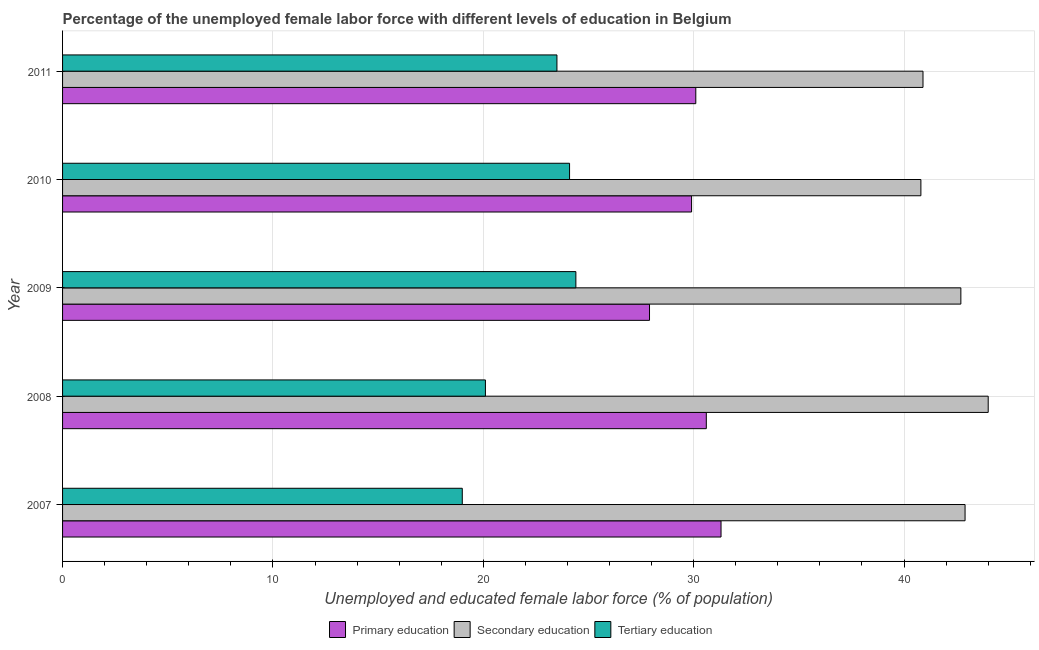How many different coloured bars are there?
Your answer should be very brief. 3. How many groups of bars are there?
Give a very brief answer. 5. Are the number of bars per tick equal to the number of legend labels?
Keep it short and to the point. Yes. How many bars are there on the 4th tick from the top?
Give a very brief answer. 3. How many bars are there on the 5th tick from the bottom?
Provide a short and direct response. 3. What is the label of the 1st group of bars from the top?
Offer a terse response. 2011. In how many cases, is the number of bars for a given year not equal to the number of legend labels?
Offer a very short reply. 0. What is the percentage of female labor force who received tertiary education in 2010?
Ensure brevity in your answer.  24.1. Across all years, what is the maximum percentage of female labor force who received secondary education?
Your response must be concise. 44. Across all years, what is the minimum percentage of female labor force who received tertiary education?
Provide a succinct answer. 19. In which year was the percentage of female labor force who received secondary education maximum?
Offer a very short reply. 2008. What is the total percentage of female labor force who received secondary education in the graph?
Your response must be concise. 211.3. What is the difference between the percentage of female labor force who received primary education in 2007 and the percentage of female labor force who received tertiary education in 2011?
Offer a very short reply. 7.8. What is the average percentage of female labor force who received tertiary education per year?
Ensure brevity in your answer.  22.22. What is the ratio of the percentage of female labor force who received secondary education in 2007 to that in 2010?
Give a very brief answer. 1.05. Is the percentage of female labor force who received primary education in 2009 less than that in 2011?
Offer a terse response. Yes. What is the difference between the highest and the lowest percentage of female labor force who received primary education?
Your response must be concise. 3.4. What does the 2nd bar from the top in 2007 represents?
Provide a short and direct response. Secondary education. What does the 1st bar from the bottom in 2010 represents?
Your answer should be very brief. Primary education. Are all the bars in the graph horizontal?
Ensure brevity in your answer.  Yes. How many years are there in the graph?
Your answer should be very brief. 5. What is the difference between two consecutive major ticks on the X-axis?
Your answer should be very brief. 10. Does the graph contain any zero values?
Offer a terse response. No. Does the graph contain grids?
Ensure brevity in your answer.  Yes. What is the title of the graph?
Keep it short and to the point. Percentage of the unemployed female labor force with different levels of education in Belgium. Does "Refusal of sex" appear as one of the legend labels in the graph?
Your response must be concise. No. What is the label or title of the X-axis?
Make the answer very short. Unemployed and educated female labor force (% of population). What is the Unemployed and educated female labor force (% of population) of Primary education in 2007?
Your answer should be compact. 31.3. What is the Unemployed and educated female labor force (% of population) in Secondary education in 2007?
Your answer should be compact. 42.9. What is the Unemployed and educated female labor force (% of population) of Primary education in 2008?
Provide a short and direct response. 30.6. What is the Unemployed and educated female labor force (% of population) of Secondary education in 2008?
Give a very brief answer. 44. What is the Unemployed and educated female labor force (% of population) of Tertiary education in 2008?
Offer a terse response. 20.1. What is the Unemployed and educated female labor force (% of population) in Primary education in 2009?
Ensure brevity in your answer.  27.9. What is the Unemployed and educated female labor force (% of population) in Secondary education in 2009?
Ensure brevity in your answer.  42.7. What is the Unemployed and educated female labor force (% of population) of Tertiary education in 2009?
Your response must be concise. 24.4. What is the Unemployed and educated female labor force (% of population) in Primary education in 2010?
Give a very brief answer. 29.9. What is the Unemployed and educated female labor force (% of population) of Secondary education in 2010?
Offer a terse response. 40.8. What is the Unemployed and educated female labor force (% of population) in Tertiary education in 2010?
Provide a short and direct response. 24.1. What is the Unemployed and educated female labor force (% of population) in Primary education in 2011?
Give a very brief answer. 30.1. What is the Unemployed and educated female labor force (% of population) of Secondary education in 2011?
Offer a terse response. 40.9. Across all years, what is the maximum Unemployed and educated female labor force (% of population) of Primary education?
Give a very brief answer. 31.3. Across all years, what is the maximum Unemployed and educated female labor force (% of population) of Secondary education?
Your answer should be compact. 44. Across all years, what is the maximum Unemployed and educated female labor force (% of population) in Tertiary education?
Offer a very short reply. 24.4. Across all years, what is the minimum Unemployed and educated female labor force (% of population) in Primary education?
Offer a terse response. 27.9. Across all years, what is the minimum Unemployed and educated female labor force (% of population) of Secondary education?
Offer a terse response. 40.8. What is the total Unemployed and educated female labor force (% of population) of Primary education in the graph?
Offer a very short reply. 149.8. What is the total Unemployed and educated female labor force (% of population) of Secondary education in the graph?
Offer a very short reply. 211.3. What is the total Unemployed and educated female labor force (% of population) of Tertiary education in the graph?
Your answer should be compact. 111.1. What is the difference between the Unemployed and educated female labor force (% of population) of Primary education in 2007 and that in 2008?
Offer a terse response. 0.7. What is the difference between the Unemployed and educated female labor force (% of population) in Secondary education in 2007 and that in 2010?
Offer a very short reply. 2.1. What is the difference between the Unemployed and educated female labor force (% of population) in Primary education in 2007 and that in 2011?
Your response must be concise. 1.2. What is the difference between the Unemployed and educated female labor force (% of population) of Primary education in 2008 and that in 2009?
Your response must be concise. 2.7. What is the difference between the Unemployed and educated female labor force (% of population) in Secondary education in 2008 and that in 2009?
Provide a succinct answer. 1.3. What is the difference between the Unemployed and educated female labor force (% of population) of Primary education in 2009 and that in 2010?
Keep it short and to the point. -2. What is the difference between the Unemployed and educated female labor force (% of population) of Secondary education in 2009 and that in 2010?
Keep it short and to the point. 1.9. What is the difference between the Unemployed and educated female labor force (% of population) in Secondary education in 2009 and that in 2011?
Your response must be concise. 1.8. What is the difference between the Unemployed and educated female labor force (% of population) in Primary education in 2010 and that in 2011?
Provide a short and direct response. -0.2. What is the difference between the Unemployed and educated female labor force (% of population) in Secondary education in 2010 and that in 2011?
Your answer should be very brief. -0.1. What is the difference between the Unemployed and educated female labor force (% of population) in Tertiary education in 2010 and that in 2011?
Your answer should be compact. 0.6. What is the difference between the Unemployed and educated female labor force (% of population) in Primary education in 2007 and the Unemployed and educated female labor force (% of population) in Secondary education in 2008?
Provide a succinct answer. -12.7. What is the difference between the Unemployed and educated female labor force (% of population) in Secondary education in 2007 and the Unemployed and educated female labor force (% of population) in Tertiary education in 2008?
Offer a very short reply. 22.8. What is the difference between the Unemployed and educated female labor force (% of population) of Primary education in 2007 and the Unemployed and educated female labor force (% of population) of Secondary education in 2009?
Ensure brevity in your answer.  -11.4. What is the difference between the Unemployed and educated female labor force (% of population) in Secondary education in 2007 and the Unemployed and educated female labor force (% of population) in Tertiary education in 2009?
Provide a succinct answer. 18.5. What is the difference between the Unemployed and educated female labor force (% of population) in Primary education in 2007 and the Unemployed and educated female labor force (% of population) in Tertiary education in 2010?
Provide a succinct answer. 7.2. What is the difference between the Unemployed and educated female labor force (% of population) of Secondary education in 2007 and the Unemployed and educated female labor force (% of population) of Tertiary education in 2011?
Provide a succinct answer. 19.4. What is the difference between the Unemployed and educated female labor force (% of population) in Primary education in 2008 and the Unemployed and educated female labor force (% of population) in Secondary education in 2009?
Offer a very short reply. -12.1. What is the difference between the Unemployed and educated female labor force (% of population) in Secondary education in 2008 and the Unemployed and educated female labor force (% of population) in Tertiary education in 2009?
Offer a terse response. 19.6. What is the difference between the Unemployed and educated female labor force (% of population) of Primary education in 2008 and the Unemployed and educated female labor force (% of population) of Tertiary education in 2010?
Give a very brief answer. 6.5. What is the difference between the Unemployed and educated female labor force (% of population) of Secondary education in 2008 and the Unemployed and educated female labor force (% of population) of Tertiary education in 2010?
Ensure brevity in your answer.  19.9. What is the difference between the Unemployed and educated female labor force (% of population) in Primary education in 2008 and the Unemployed and educated female labor force (% of population) in Tertiary education in 2011?
Give a very brief answer. 7.1. What is the difference between the Unemployed and educated female labor force (% of population) in Secondary education in 2008 and the Unemployed and educated female labor force (% of population) in Tertiary education in 2011?
Make the answer very short. 20.5. What is the difference between the Unemployed and educated female labor force (% of population) of Primary education in 2009 and the Unemployed and educated female labor force (% of population) of Secondary education in 2010?
Provide a succinct answer. -12.9. What is the difference between the Unemployed and educated female labor force (% of population) in Primary education in 2009 and the Unemployed and educated female labor force (% of population) in Tertiary education in 2010?
Your response must be concise. 3.8. What is the difference between the Unemployed and educated female labor force (% of population) in Secondary education in 2009 and the Unemployed and educated female labor force (% of population) in Tertiary education in 2010?
Your response must be concise. 18.6. What is the difference between the Unemployed and educated female labor force (% of population) of Primary education in 2009 and the Unemployed and educated female labor force (% of population) of Secondary education in 2011?
Your answer should be compact. -13. What is the difference between the Unemployed and educated female labor force (% of population) in Primary education in 2009 and the Unemployed and educated female labor force (% of population) in Tertiary education in 2011?
Provide a succinct answer. 4.4. What is the difference between the Unemployed and educated female labor force (% of population) in Primary education in 2010 and the Unemployed and educated female labor force (% of population) in Secondary education in 2011?
Your answer should be very brief. -11. What is the average Unemployed and educated female labor force (% of population) in Primary education per year?
Provide a succinct answer. 29.96. What is the average Unemployed and educated female labor force (% of population) in Secondary education per year?
Provide a short and direct response. 42.26. What is the average Unemployed and educated female labor force (% of population) of Tertiary education per year?
Give a very brief answer. 22.22. In the year 2007, what is the difference between the Unemployed and educated female labor force (% of population) in Secondary education and Unemployed and educated female labor force (% of population) in Tertiary education?
Your answer should be very brief. 23.9. In the year 2008, what is the difference between the Unemployed and educated female labor force (% of population) in Secondary education and Unemployed and educated female labor force (% of population) in Tertiary education?
Provide a succinct answer. 23.9. In the year 2009, what is the difference between the Unemployed and educated female labor force (% of population) in Primary education and Unemployed and educated female labor force (% of population) in Secondary education?
Your answer should be very brief. -14.8. In the year 2010, what is the difference between the Unemployed and educated female labor force (% of population) in Secondary education and Unemployed and educated female labor force (% of population) in Tertiary education?
Offer a very short reply. 16.7. In the year 2011, what is the difference between the Unemployed and educated female labor force (% of population) of Primary education and Unemployed and educated female labor force (% of population) of Secondary education?
Your response must be concise. -10.8. In the year 2011, what is the difference between the Unemployed and educated female labor force (% of population) in Secondary education and Unemployed and educated female labor force (% of population) in Tertiary education?
Provide a short and direct response. 17.4. What is the ratio of the Unemployed and educated female labor force (% of population) of Primary education in 2007 to that in 2008?
Your answer should be compact. 1.02. What is the ratio of the Unemployed and educated female labor force (% of population) in Tertiary education in 2007 to that in 2008?
Offer a terse response. 0.95. What is the ratio of the Unemployed and educated female labor force (% of population) of Primary education in 2007 to that in 2009?
Give a very brief answer. 1.12. What is the ratio of the Unemployed and educated female labor force (% of population) in Tertiary education in 2007 to that in 2009?
Ensure brevity in your answer.  0.78. What is the ratio of the Unemployed and educated female labor force (% of population) in Primary education in 2007 to that in 2010?
Make the answer very short. 1.05. What is the ratio of the Unemployed and educated female labor force (% of population) in Secondary education in 2007 to that in 2010?
Make the answer very short. 1.05. What is the ratio of the Unemployed and educated female labor force (% of population) of Tertiary education in 2007 to that in 2010?
Give a very brief answer. 0.79. What is the ratio of the Unemployed and educated female labor force (% of population) in Primary education in 2007 to that in 2011?
Provide a succinct answer. 1.04. What is the ratio of the Unemployed and educated female labor force (% of population) of Secondary education in 2007 to that in 2011?
Offer a terse response. 1.05. What is the ratio of the Unemployed and educated female labor force (% of population) in Tertiary education in 2007 to that in 2011?
Offer a terse response. 0.81. What is the ratio of the Unemployed and educated female labor force (% of population) in Primary education in 2008 to that in 2009?
Your answer should be very brief. 1.1. What is the ratio of the Unemployed and educated female labor force (% of population) in Secondary education in 2008 to that in 2009?
Your answer should be compact. 1.03. What is the ratio of the Unemployed and educated female labor force (% of population) of Tertiary education in 2008 to that in 2009?
Your response must be concise. 0.82. What is the ratio of the Unemployed and educated female labor force (% of population) of Primary education in 2008 to that in 2010?
Offer a very short reply. 1.02. What is the ratio of the Unemployed and educated female labor force (% of population) in Secondary education in 2008 to that in 2010?
Provide a succinct answer. 1.08. What is the ratio of the Unemployed and educated female labor force (% of population) in Tertiary education in 2008 to that in 2010?
Provide a succinct answer. 0.83. What is the ratio of the Unemployed and educated female labor force (% of population) in Primary education in 2008 to that in 2011?
Offer a very short reply. 1.02. What is the ratio of the Unemployed and educated female labor force (% of population) of Secondary education in 2008 to that in 2011?
Your answer should be compact. 1.08. What is the ratio of the Unemployed and educated female labor force (% of population) in Tertiary education in 2008 to that in 2011?
Your answer should be very brief. 0.86. What is the ratio of the Unemployed and educated female labor force (% of population) in Primary education in 2009 to that in 2010?
Offer a very short reply. 0.93. What is the ratio of the Unemployed and educated female labor force (% of population) of Secondary education in 2009 to that in 2010?
Your answer should be compact. 1.05. What is the ratio of the Unemployed and educated female labor force (% of population) in Tertiary education in 2009 to that in 2010?
Make the answer very short. 1.01. What is the ratio of the Unemployed and educated female labor force (% of population) in Primary education in 2009 to that in 2011?
Keep it short and to the point. 0.93. What is the ratio of the Unemployed and educated female labor force (% of population) of Secondary education in 2009 to that in 2011?
Give a very brief answer. 1.04. What is the ratio of the Unemployed and educated female labor force (% of population) in Tertiary education in 2009 to that in 2011?
Offer a very short reply. 1.04. What is the ratio of the Unemployed and educated female labor force (% of population) of Primary education in 2010 to that in 2011?
Offer a very short reply. 0.99. What is the ratio of the Unemployed and educated female labor force (% of population) of Secondary education in 2010 to that in 2011?
Provide a short and direct response. 1. What is the ratio of the Unemployed and educated female labor force (% of population) of Tertiary education in 2010 to that in 2011?
Your answer should be very brief. 1.03. What is the difference between the highest and the second highest Unemployed and educated female labor force (% of population) of Primary education?
Provide a short and direct response. 0.7. What is the difference between the highest and the lowest Unemployed and educated female labor force (% of population) of Tertiary education?
Ensure brevity in your answer.  5.4. 